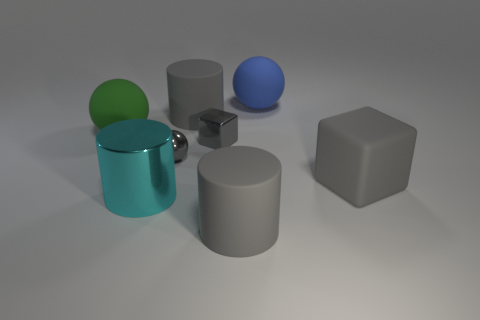Add 2 small brown metallic things. How many objects exist? 10 Subtract all blocks. How many objects are left? 6 Add 6 large blue rubber balls. How many large blue rubber balls are left? 7 Add 5 blue rubber things. How many blue rubber things exist? 6 Subtract 0 brown cylinders. How many objects are left? 8 Subtract all large cubes. Subtract all shiny cylinders. How many objects are left? 6 